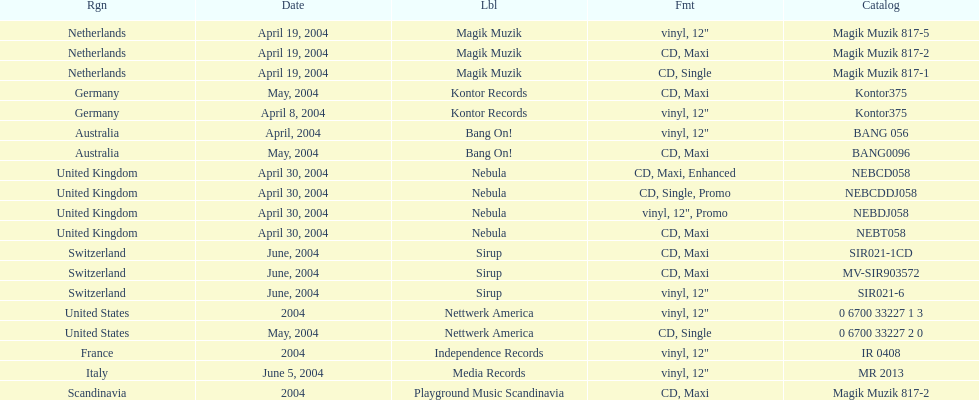What region is listed at the top? Netherlands. 